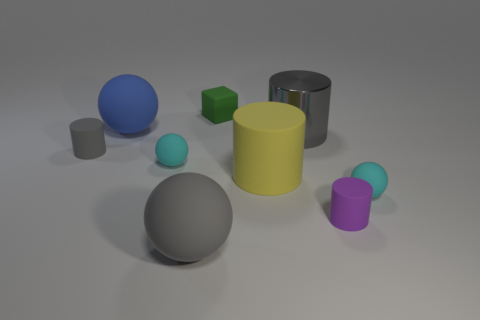Subtract all gray cylinders. How many were subtracted if there are1gray cylinders left? 1 Subtract 1 cylinders. How many cylinders are left? 3 Add 1 tiny rubber objects. How many objects exist? 10 Subtract all cylinders. How many objects are left? 5 Add 7 big rubber spheres. How many big rubber spheres exist? 9 Subtract 0 yellow blocks. How many objects are left? 9 Subtract all tiny cyan balls. Subtract all big gray metal cylinders. How many objects are left? 6 Add 5 large gray shiny objects. How many large gray shiny objects are left? 6 